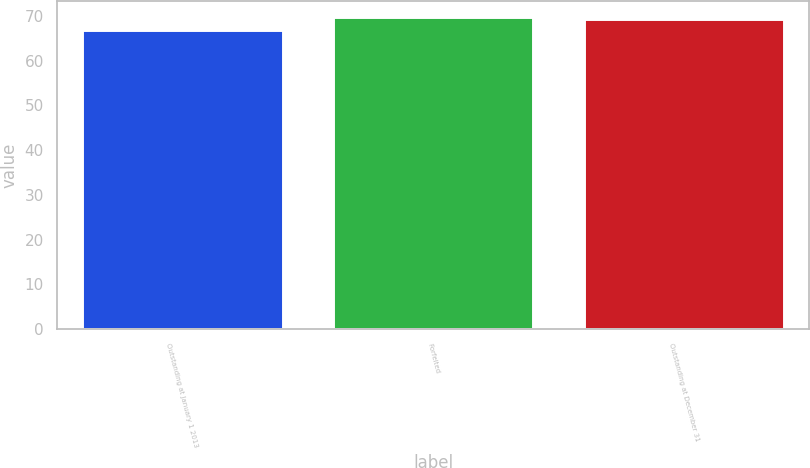Convert chart. <chart><loc_0><loc_0><loc_500><loc_500><bar_chart><fcel>Outstanding at January 1 2013<fcel>Forfeited<fcel>Outstanding at December 31<nl><fcel>66.89<fcel>69.78<fcel>69.36<nl></chart> 